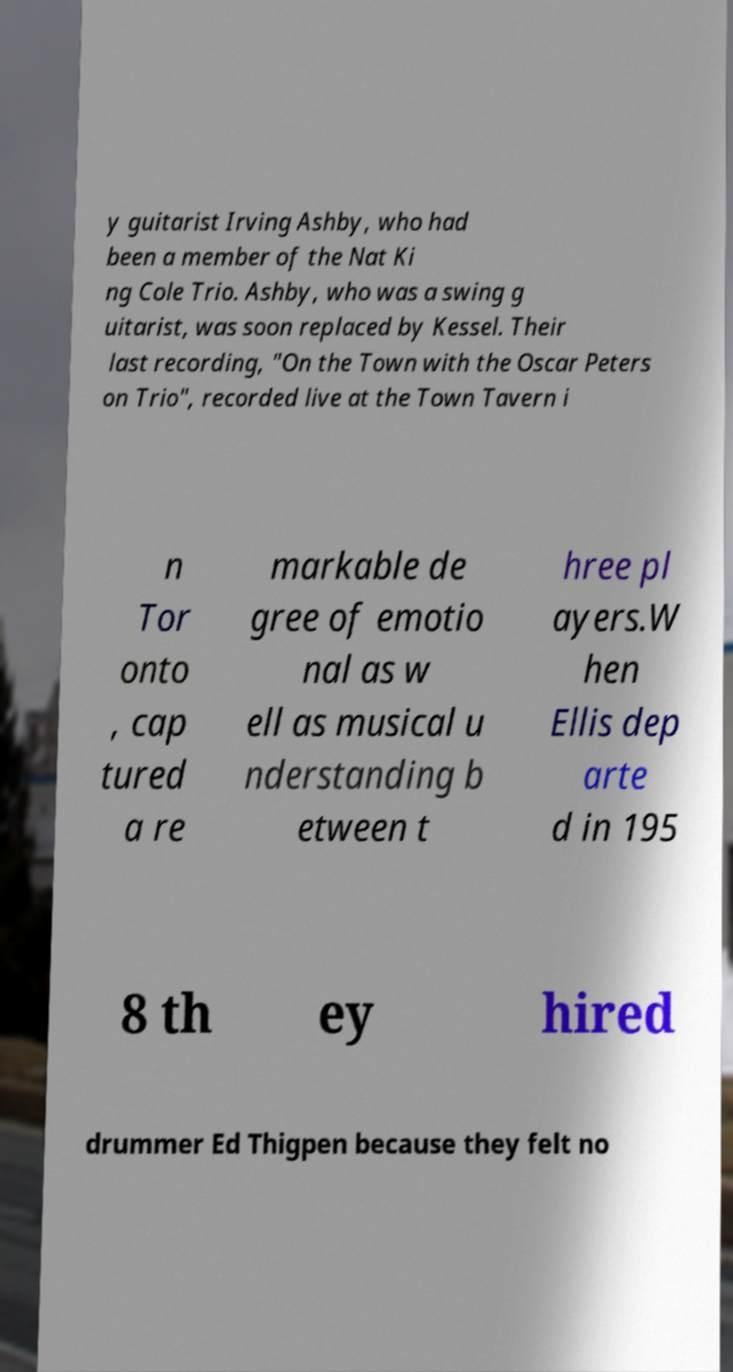Please identify and transcribe the text found in this image. y guitarist Irving Ashby, who had been a member of the Nat Ki ng Cole Trio. Ashby, who was a swing g uitarist, was soon replaced by Kessel. Their last recording, "On the Town with the Oscar Peters on Trio", recorded live at the Town Tavern i n Tor onto , cap tured a re markable de gree of emotio nal as w ell as musical u nderstanding b etween t hree pl ayers.W hen Ellis dep arte d in 195 8 th ey hired drummer Ed Thigpen because they felt no 